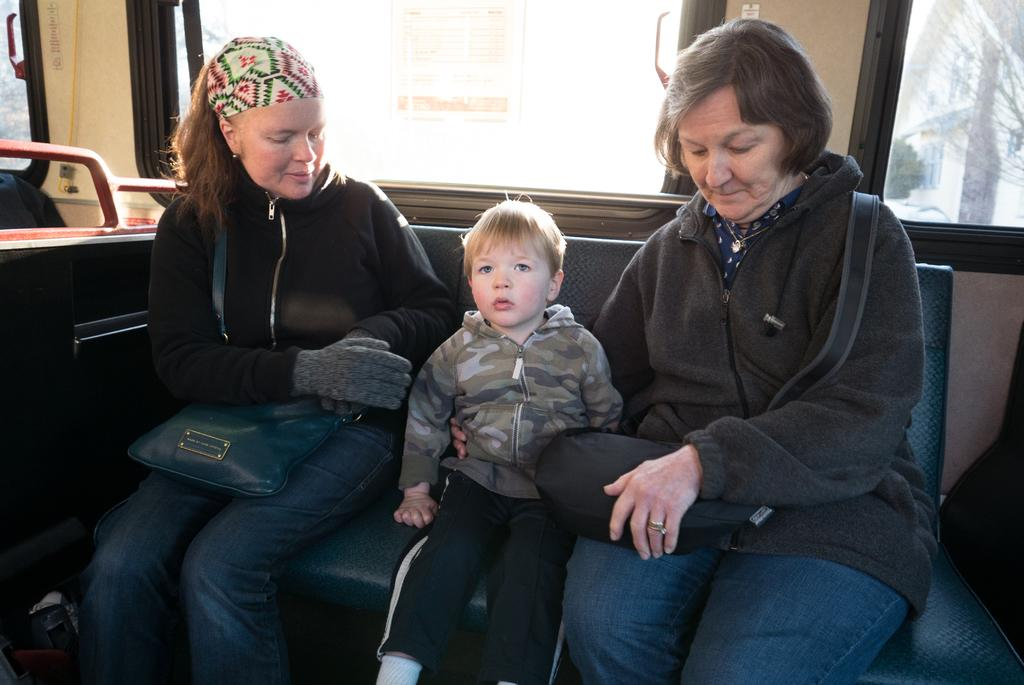What is the main subject of the image? The main subject of the image is a bus. Can you describe the people inside the bus? There are three persons sitting on a seat in the bus. What type of window is present at the back of the bus? There is a glass window at the back of the bus. How many dimes are visible on the floor of the bus in the image? There are no dimes visible on the floor of the bus in the image. What type of haircut is the person in the middle of the seat getting in the image? There is no person getting a haircut in the image; the three persons are simply sitting on a seat. 